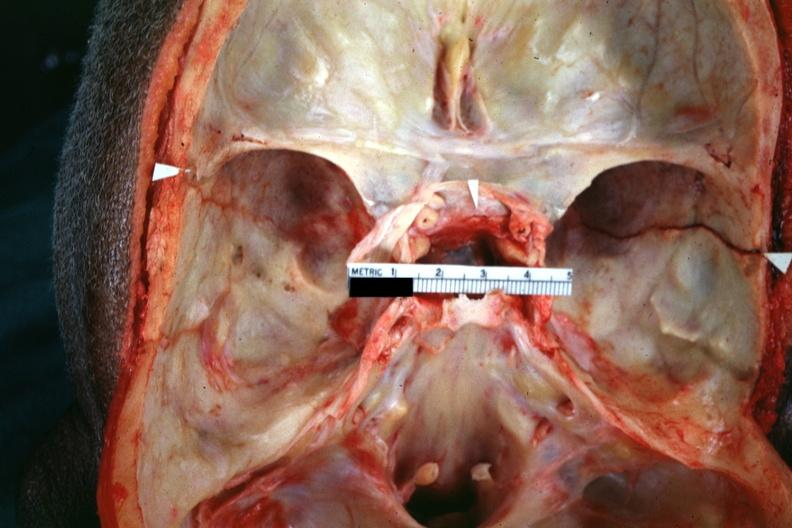what does this image show?
Answer the question using a single word or phrase. Close-up view well shown fracture line 